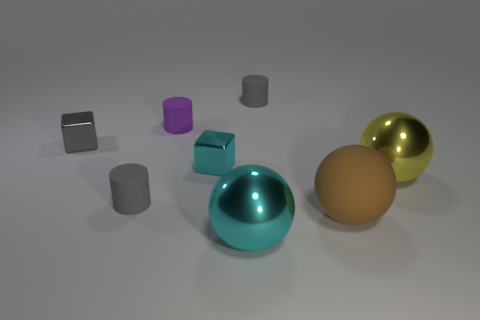Is the size of the rubber ball the same as the gray cylinder behind the tiny purple rubber cylinder? No, the size of the rubber ball is not the same as the gray cylinder behind the tiny purple rubber cylinder. The ball appears to be larger in diameter compared to the height and width of the gray cylinder when evaluating their relative sizes displayed in the image. 